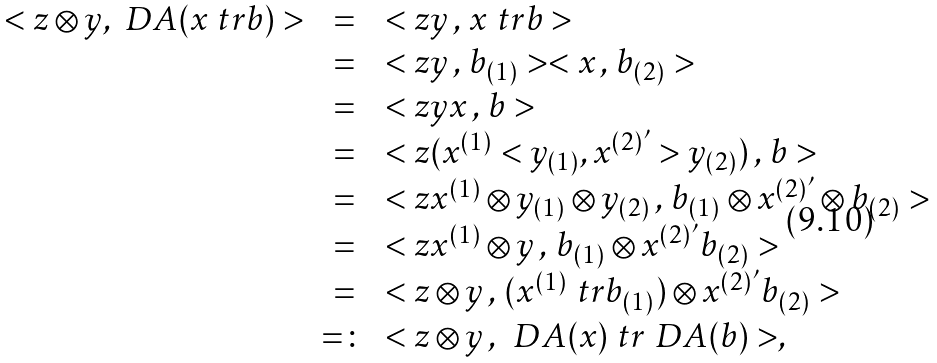<formula> <loc_0><loc_0><loc_500><loc_500>\begin{array} { r c l } < z \otimes y , \ D A ( x \ t r b ) > & = & < z y \, , \, x \ t r b > \\ & = & < z y \, , \, b _ { ( 1 ) } > < x \, , \, b _ { ( 2 ) } > \\ & = & < z y x \, , \, b > \\ & = & < z ( x ^ { ( 1 ) } < y _ { ( 1 ) } , x ^ { ( 2 ) ^ { \prime } } > y _ { ( 2 ) } ) \, , \, b > \\ & = & < z x ^ { ( 1 ) } \otimes y _ { ( 1 ) } \otimes y _ { ( 2 ) } \, , \, b _ { ( 1 ) } \otimes x ^ { ( 2 ) ^ { \prime } } \otimes b _ { ( 2 ) } > \\ & = & < z x ^ { ( 1 ) } \otimes y \, , \, b _ { ( 1 ) } \otimes x ^ { ( 2 ) ^ { \prime } } b _ { ( 2 ) } > \\ & = & < z \otimes y \, , \, ( x ^ { ( 1 ) } \ t r b _ { ( 1 ) } ) \otimes x ^ { ( 2 ) ^ { \prime } } b _ { ( 2 ) } > \\ & = \colon & < z \otimes y \, , \, \ D A ( x ) \ t r \ D A ( b ) > , \end{array}</formula> 